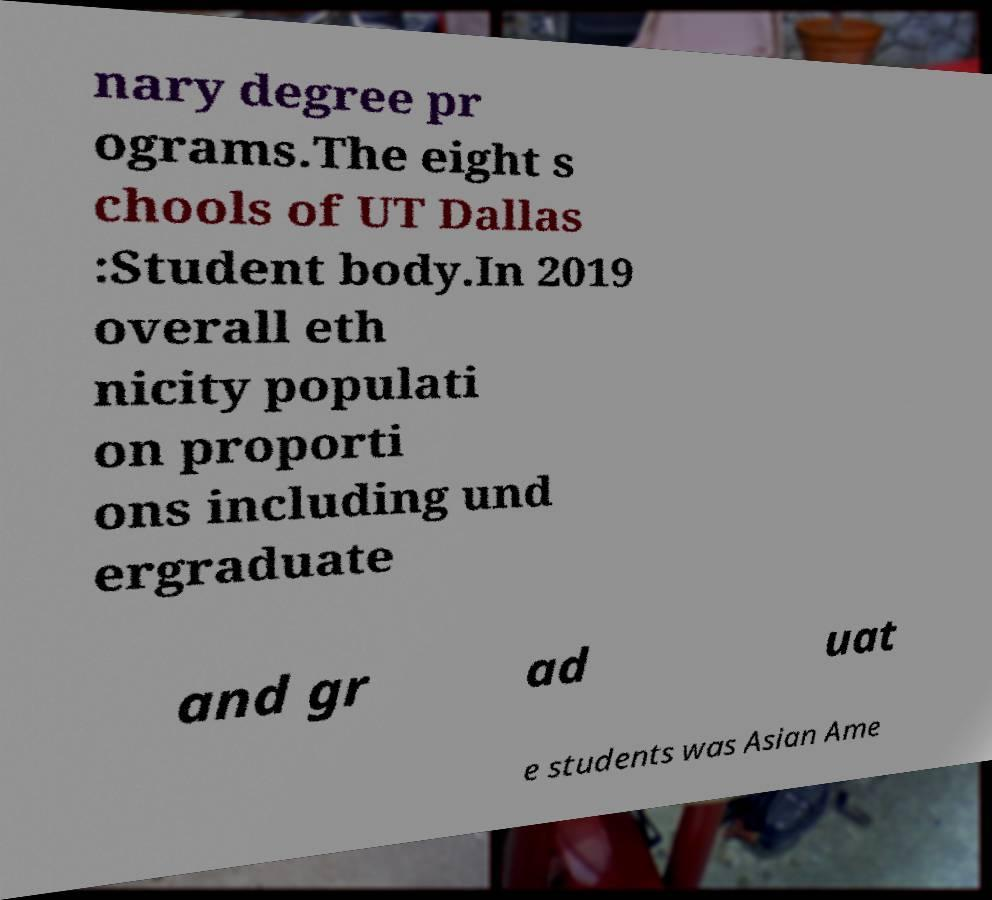Please identify and transcribe the text found in this image. nary degree pr ograms.The eight s chools of UT Dallas :Student body.In 2019 overall eth nicity populati on proporti ons including und ergraduate and gr ad uat e students was Asian Ame 